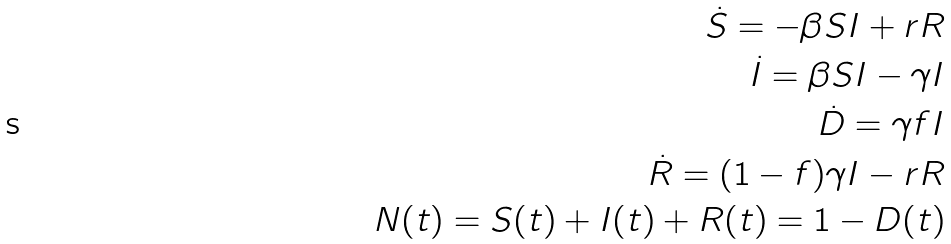Convert formula to latex. <formula><loc_0><loc_0><loc_500><loc_500>\dot { S } = - \beta S I + r R \\ \dot { I } = \beta S I - \gamma I \\ \dot { D } = \gamma f I \\ \dot { R } = ( 1 - f ) \gamma I - r R \\ N ( t ) = S ( t ) + I ( t ) + R ( t ) = 1 - D ( t )</formula> 